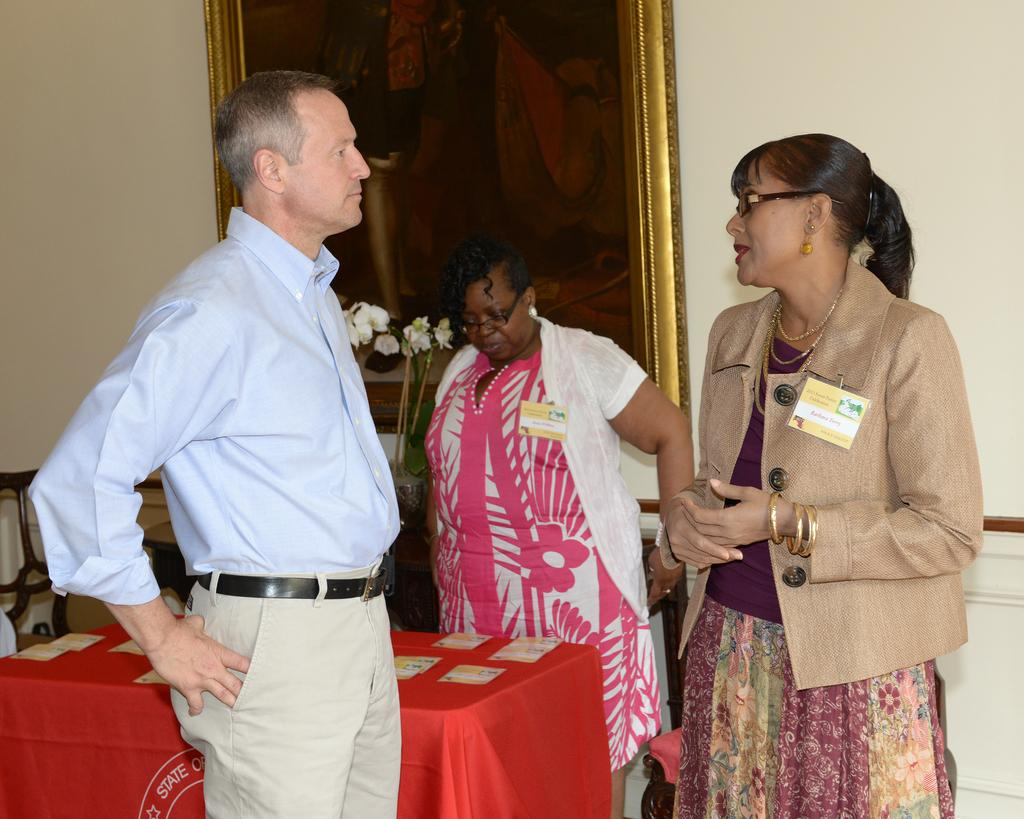How many people are in the picture? There are three people in the picture. Can you describe the gender of the people? Two of them are women, and one of them is a man. What are the people doing in the image? The people are talking. What can be seen on the table in the image? There is a red table in the image. What is present in the background of the image? There is a photo frame and a wall in the background. Is there a throne visible in the image? No, there is no throne present in the image. Are there any cobwebs visible in the image? No, there are no cobwebs present in the image. 